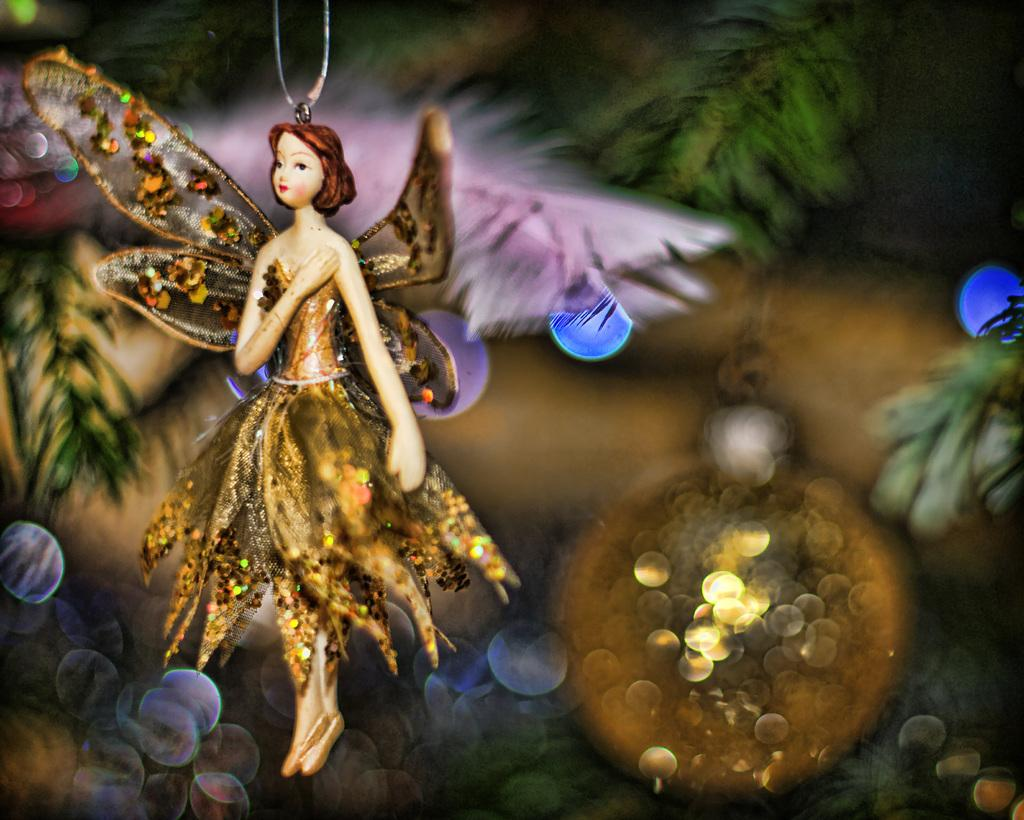What is the main subject of the image? The main subject of the image is a pendant. Can you describe the pendant in more detail? The pendant appears to be an angel. How is the pendant attached or suspended in the image? The pendant is hanging from a chain. What can be observed about the background of the image? The background of the image is colorful. What type of bone can be seen in the image? There is no bone present in the image; it features a pendant that appears to be an angel hanging from a chain. How many buckets are visible in the image? There are no buckets present in the image. 